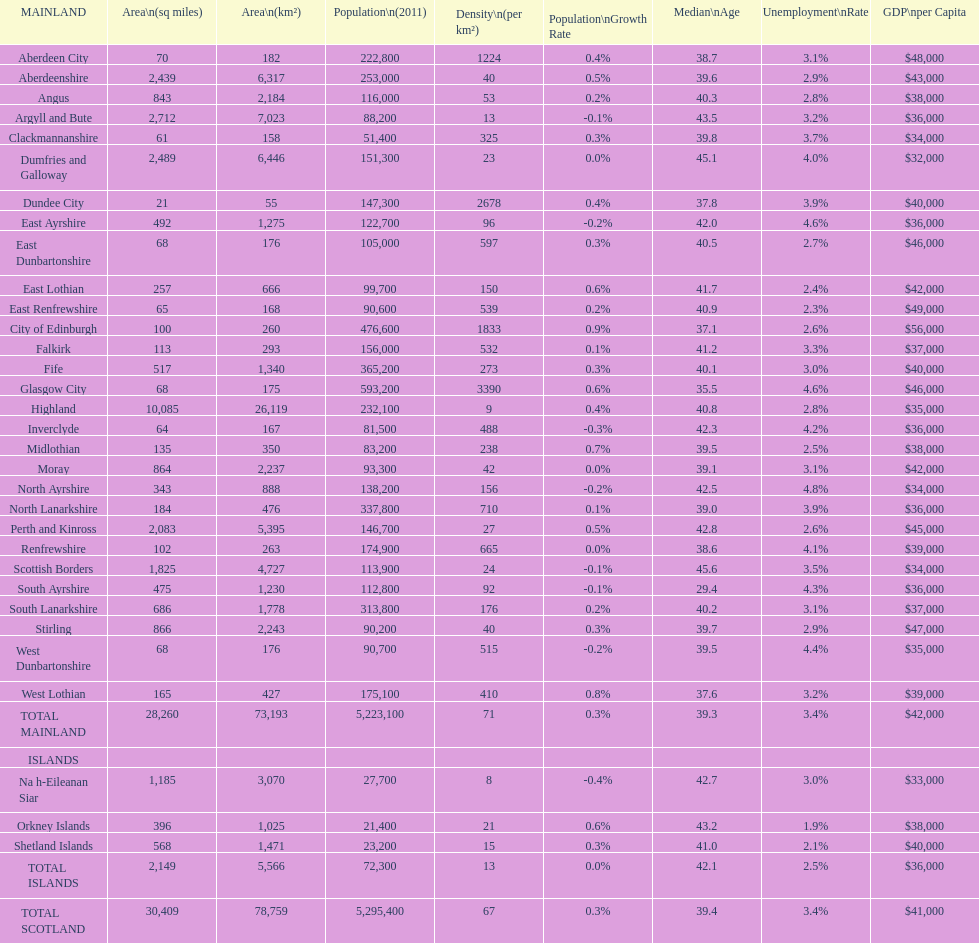Which mainland has the least population? Clackmannanshire. 